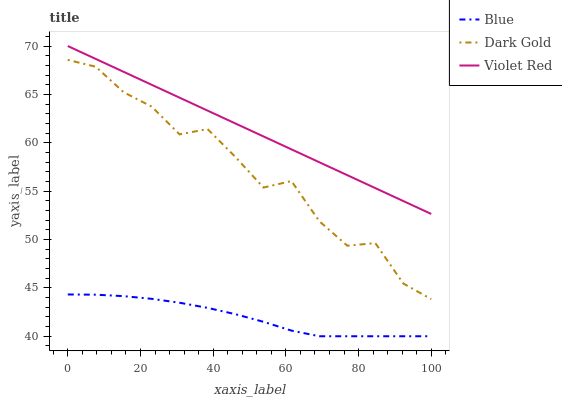Does Blue have the minimum area under the curve?
Answer yes or no. Yes. Does Violet Red have the maximum area under the curve?
Answer yes or no. Yes. Does Dark Gold have the minimum area under the curve?
Answer yes or no. No. Does Dark Gold have the maximum area under the curve?
Answer yes or no. No. Is Violet Red the smoothest?
Answer yes or no. Yes. Is Dark Gold the roughest?
Answer yes or no. Yes. Is Dark Gold the smoothest?
Answer yes or no. No. Is Violet Red the roughest?
Answer yes or no. No. Does Blue have the lowest value?
Answer yes or no. Yes. Does Dark Gold have the lowest value?
Answer yes or no. No. Does Violet Red have the highest value?
Answer yes or no. Yes. Does Dark Gold have the highest value?
Answer yes or no. No. Is Blue less than Violet Red?
Answer yes or no. Yes. Is Violet Red greater than Dark Gold?
Answer yes or no. Yes. Does Blue intersect Violet Red?
Answer yes or no. No. 